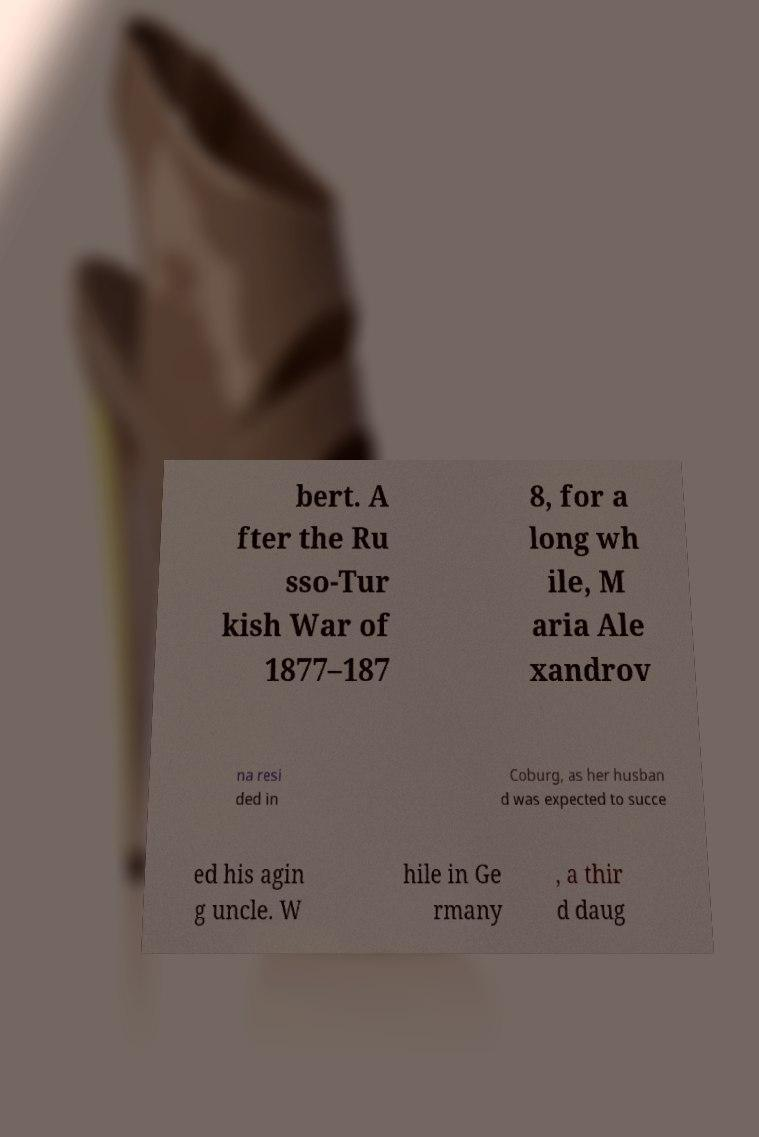Can you accurately transcribe the text from the provided image for me? bert. A fter the Ru sso-Tur kish War of 1877–187 8, for a long wh ile, M aria Ale xandrov na resi ded in Coburg, as her husban d was expected to succe ed his agin g uncle. W hile in Ge rmany , a thir d daug 